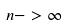Convert formula to latex. <formula><loc_0><loc_0><loc_500><loc_500>n - > \infty</formula> 